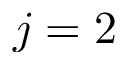<formula> <loc_0><loc_0><loc_500><loc_500>j = 2</formula> 